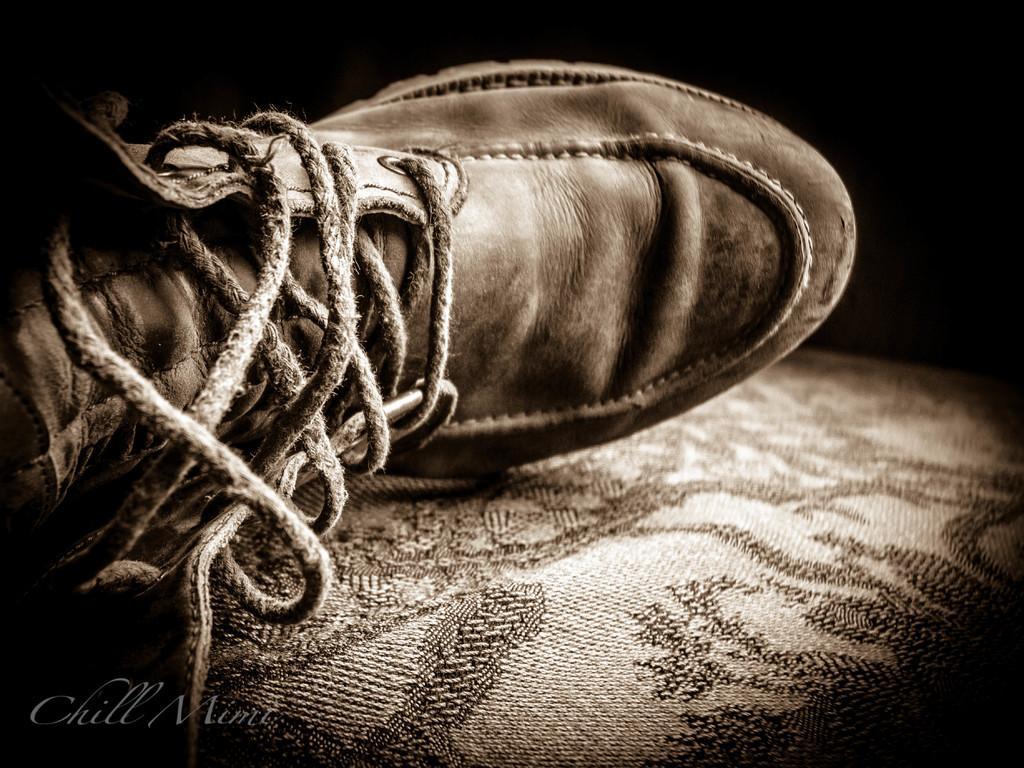Please provide a concise description of this image. In this image we can see a shoe on the couch. 